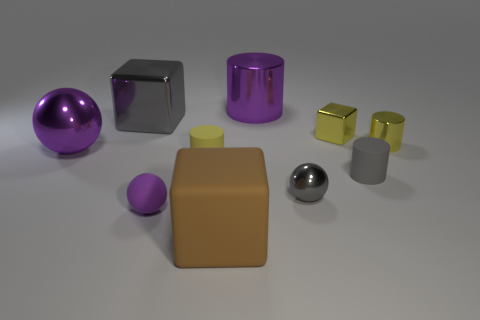What is the shape of the large metallic object that is the same color as the large sphere?
Ensure brevity in your answer.  Cylinder. Does the gray thing left of the tiny gray metallic ball have the same shape as the tiny metallic object that is to the right of the small yellow metal block?
Offer a very short reply. No. How big is the metal object in front of the tiny gray rubber thing?
Keep it short and to the point. Small. What size is the matte cylinder right of the purple thing that is to the right of the tiny purple sphere?
Ensure brevity in your answer.  Small. Are there more small purple balls than big yellow shiny objects?
Give a very brief answer. Yes. Is the number of large gray things on the right side of the small gray metal ball greater than the number of purple metal objects that are to the left of the big purple shiny cylinder?
Ensure brevity in your answer.  No. How big is the cube that is to the left of the yellow metallic cube and to the right of the tiny purple matte object?
Make the answer very short. Large. How many yellow rubber cylinders have the same size as the gray ball?
Provide a succinct answer. 1. There is a big cylinder that is the same color as the big sphere; what material is it?
Your answer should be very brief. Metal. There is a rubber object on the right side of the matte block; is it the same shape as the big matte thing?
Provide a short and direct response. No. 